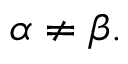<formula> <loc_0><loc_0><loc_500><loc_500>\alpha \neq \beta .</formula> 